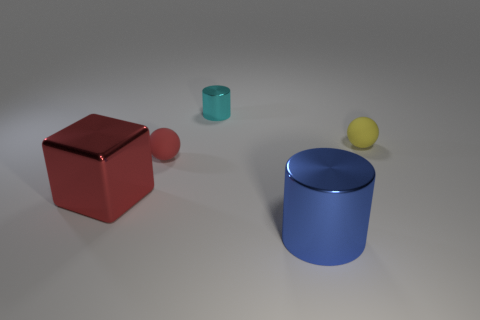Add 1 small blue matte blocks. How many objects exist? 6 Subtract all cylinders. How many objects are left? 3 Add 3 green metal blocks. How many green metal blocks exist? 3 Subtract 0 brown spheres. How many objects are left? 5 Subtract all small matte objects. Subtract all big cubes. How many objects are left? 2 Add 2 big objects. How many big objects are left? 4 